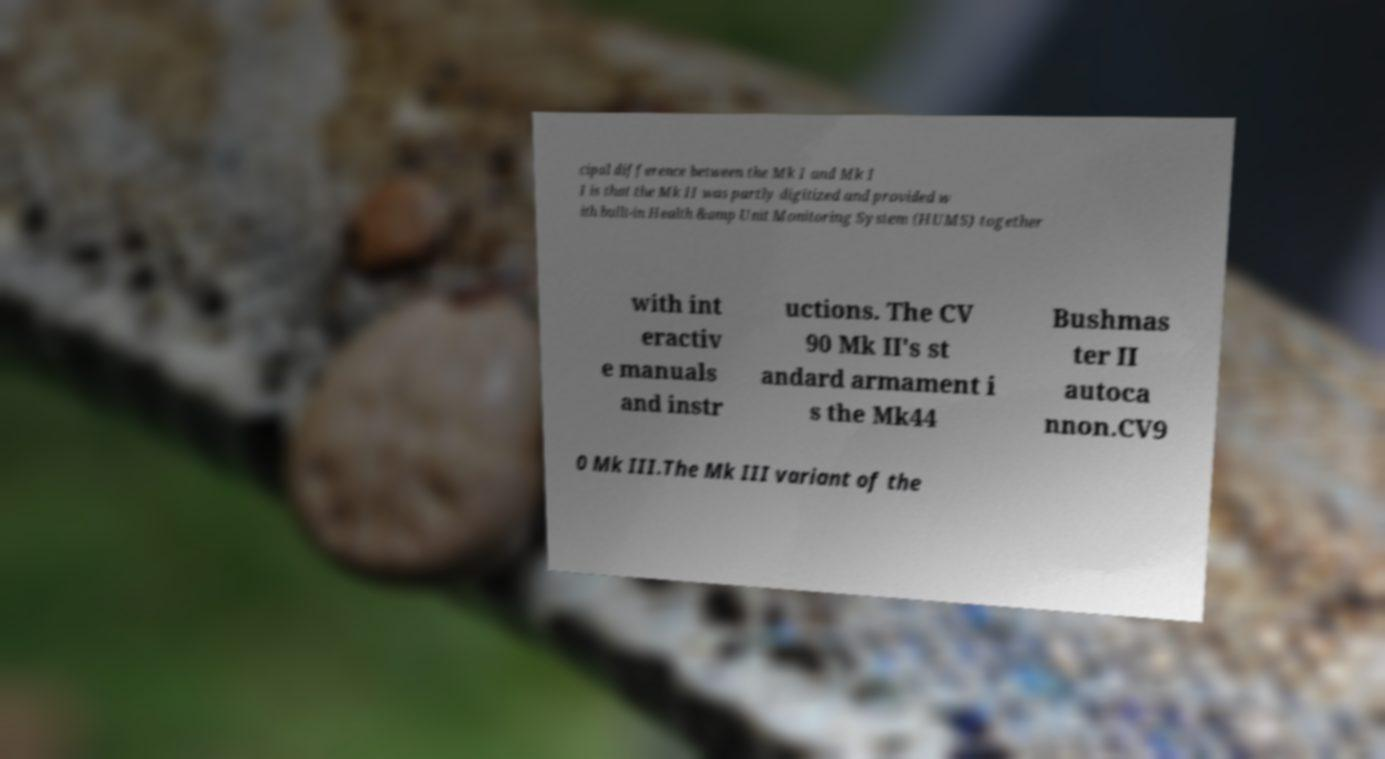Please identify and transcribe the text found in this image. cipal difference between the Mk I and Mk I I is that the Mk II was partly digitized and provided w ith built-in Health &amp Unit Monitoring System (HUMS) together with int eractiv e manuals and instr uctions. The CV 90 Mk II's st andard armament i s the Mk44 Bushmas ter II autoca nnon.CV9 0 Mk III.The Mk III variant of the 